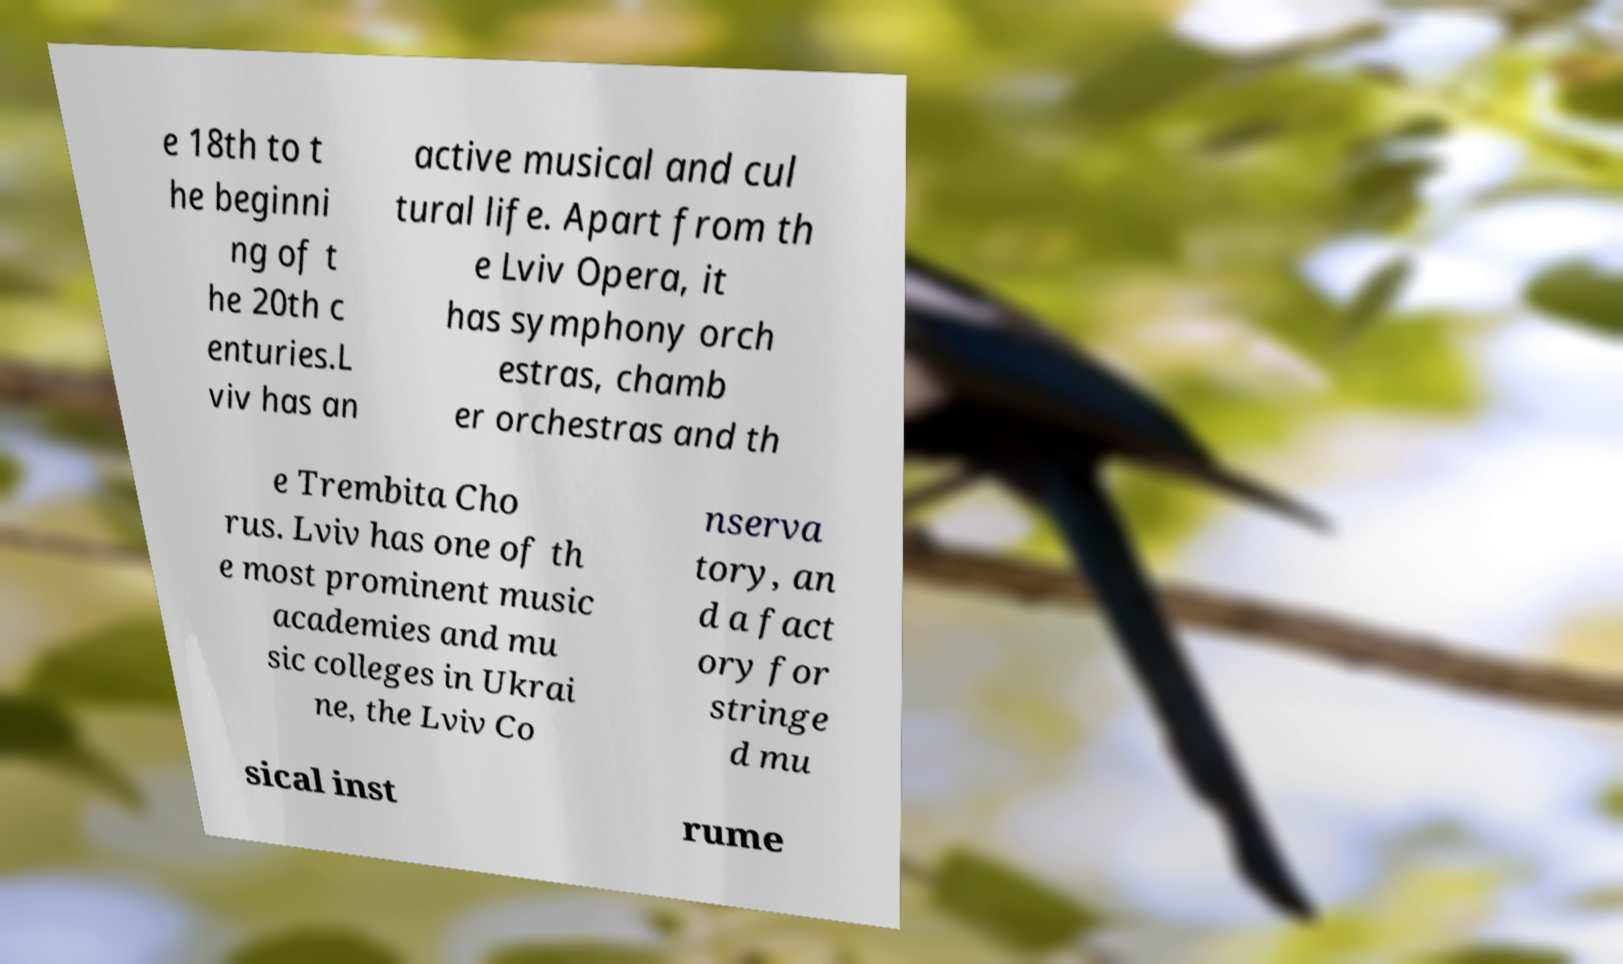Please identify and transcribe the text found in this image. e 18th to t he beginni ng of t he 20th c enturies.L viv has an active musical and cul tural life. Apart from th e Lviv Opera, it has symphony orch estras, chamb er orchestras and th e Trembita Cho rus. Lviv has one of th e most prominent music academies and mu sic colleges in Ukrai ne, the Lviv Co nserva tory, an d a fact ory for stringe d mu sical inst rume 